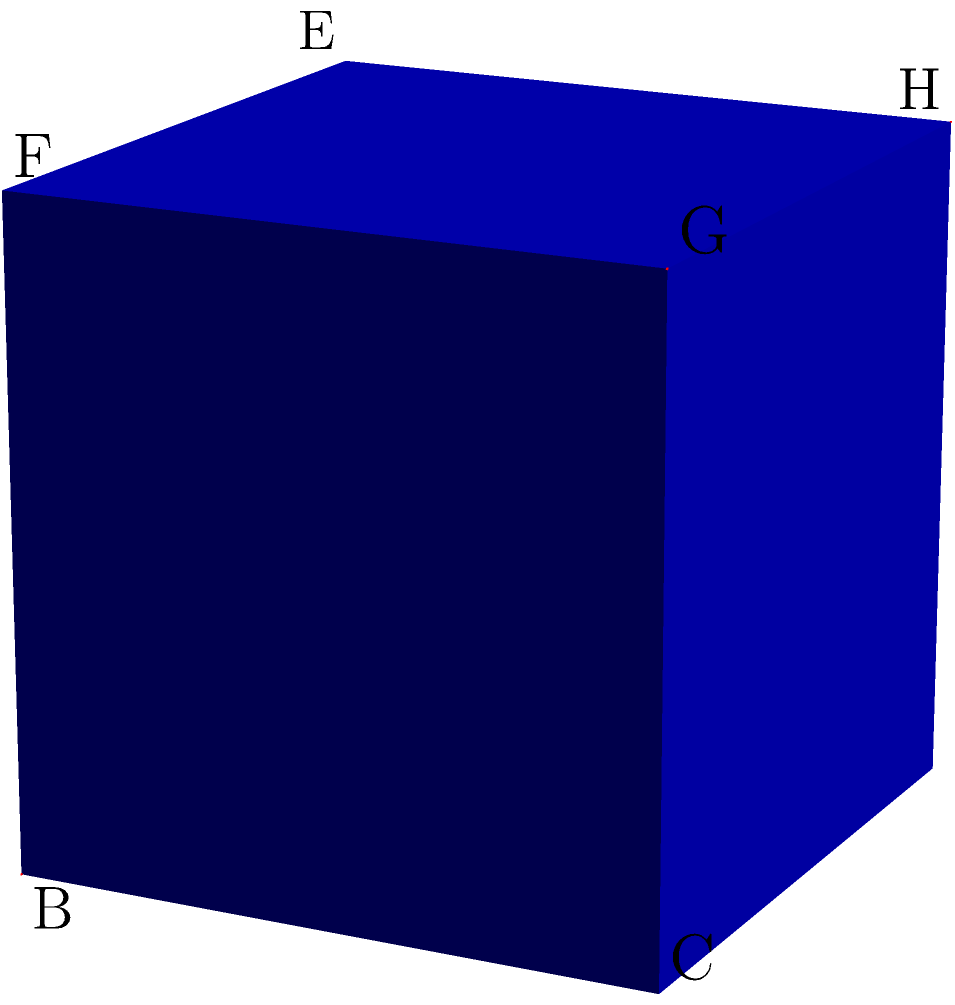In the context of marketing history, consider a cube representing different eras of advertising. Two diagonal planes intersect within this cube, symbolizing the convergence of traditional and digital marketing strategies. If these planes are represented by the triangles ABG and CDG in the cube shown, what is the angle between them? (Hint: This problem relates to how different marketing approaches intersect throughout history.) To find the angle between two planes, we can use the dot product of their normal vectors. Let's approach this step-by-step:

1) First, we need to find the normal vectors of both planes:
   For ABG: $\vec{n_1} = \vec{AB} \times \vec{AG} = (1,0,0) \times (1,1,1) = (0,-1,1)$
   For CDG: $\vec{n_2} = \vec{CD} \times \vec{CG} = (-1,1,0) \times (0,1,1) = (1,1,1)$

2) The angle $\theta$ between the planes is related to the angle between their normal vectors:
   $\cos \theta = \frac{|\vec{n_1} \cdot \vec{n_2}|}{|\vec{n_1}||\vec{n_2}|}$

3) Calculate the dot product:
   $\vec{n_1} \cdot \vec{n_2} = 0(1) + (-1)(1) + 1(1) = 0$

4) Calculate the magnitudes:
   $|\vec{n_1}| = \sqrt{0^2 + (-1)^2 + 1^2} = \sqrt{2}$
   $|\vec{n_2}| = \sqrt{1^2 + 1^2 + 1^2} = \sqrt{3}$

5) Substitute into the formula:
   $\cos \theta = \frac{|0|}{\sqrt{2}\sqrt{3}} = 0$

6) Therefore:
   $\theta = \arccos(0) = 90°$

This 90° angle symbolizes the orthogonal relationship between traditional and digital marketing strategies in the history of advertising.
Answer: 90° 